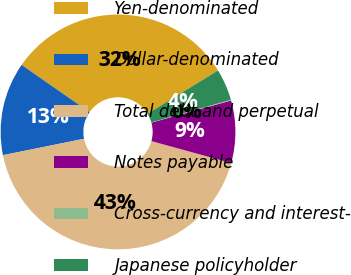Convert chart to OTSL. <chart><loc_0><loc_0><loc_500><loc_500><pie_chart><fcel>Yen-denominated<fcel>Dollar-denominated<fcel>Total debt and perpetual<fcel>Notes payable<fcel>Cross-currency and interest-<fcel>Japanese policyholder<nl><fcel>31.56%<fcel>12.84%<fcel>42.56%<fcel>8.59%<fcel>0.1%<fcel>4.35%<nl></chart> 